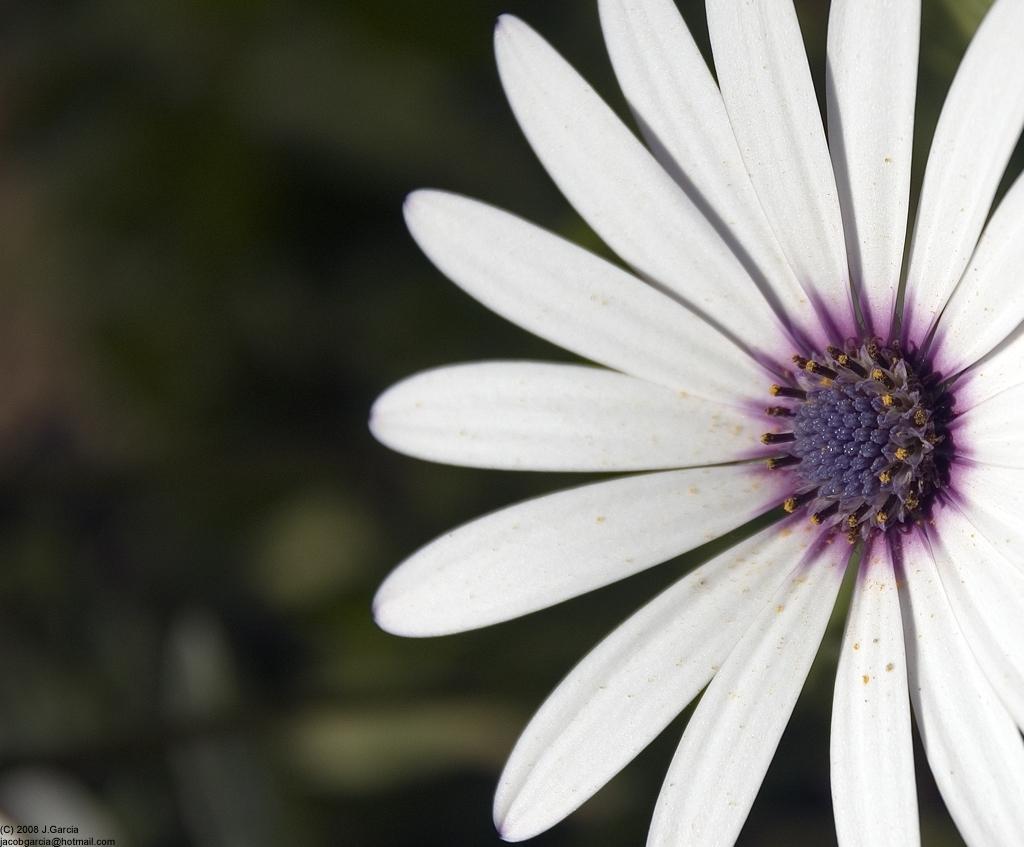Could you give a brief overview of what you see in this image? This is the image of a flower and the background is blurred. 